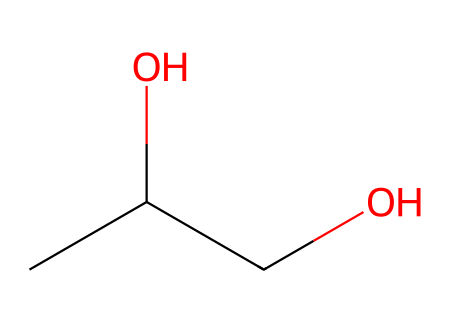How many carbon atoms are in propylene glycol? The SMILES representation CC(O)CO shows there are three carbon atoms (C) visible in the sequence. Each 'C' represents a carbon that makes up the structure of propylene glycol.
Answer: three What is the molecular formula for propylene glycol? By analyzing the SMILES representation, we see that there are three carbon atoms, eight hydrogen atoms (H), and two oxygen atoms (O). This corresponds to the molecular formula C3H8O2.
Answer: C3H8O2 How many hydroxyl (-OH) groups are present in propylene glycol? The SMILES representation contains two instances of the hydroxyl (-OH) group, identified by the 'O' in combination with hydrogen (H). Each oxygen appears with an adjacent carbon, indicating they are part of -OH groups.
Answer: two What type of chemical is propylene glycol based on its structure? The presence of hydroxyl groups in the structure indicates that propylene glycol is classified as a type of alcohol. Alcohols are characterized by the -OH functional group.
Answer: alcohol What is the role of propylene glycol in fog machine fluids? Propylene glycol serves as a humectant and solvent in fog machine fluids. Its ability to retain moisture and dissolve other chemicals helps generate fog when heated.
Answer: humectant What kind of interaction occurs because of the hydroxyl groups in propylene glycol? The hydroxyl groups can form hydrogen bonds with water molecules, enhancing solubility and allowing for interaction with other components in the fog fluid.
Answer: hydrogen bonds 